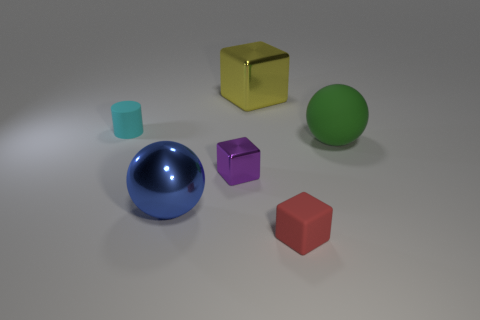Subtract all green cylinders. Subtract all blue balls. How many cylinders are left? 1 Add 3 small purple metal cubes. How many objects exist? 9 Subtract all spheres. How many objects are left? 4 Add 4 small red matte things. How many small red matte things are left? 5 Add 5 tiny blue shiny cylinders. How many tiny blue shiny cylinders exist? 5 Subtract 0 gray spheres. How many objects are left? 6 Subtract all large cyan cylinders. Subtract all small matte blocks. How many objects are left? 5 